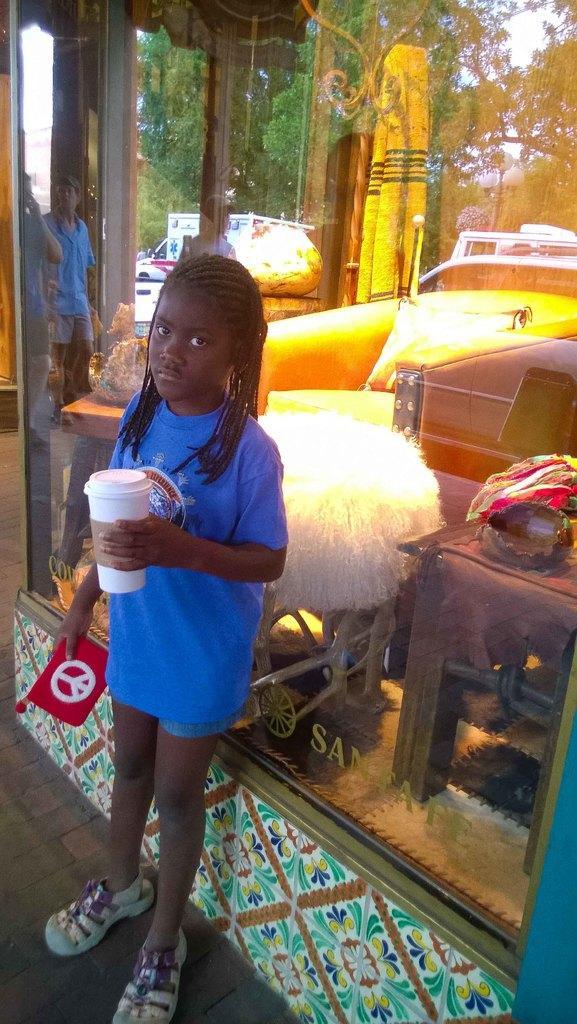Please provide a concise description of this image. In the image there is a girl standing in the foreground and she is holding a cup in her hand, behind her there is a window and inside the window there is some furniture and in the background there are trees. 